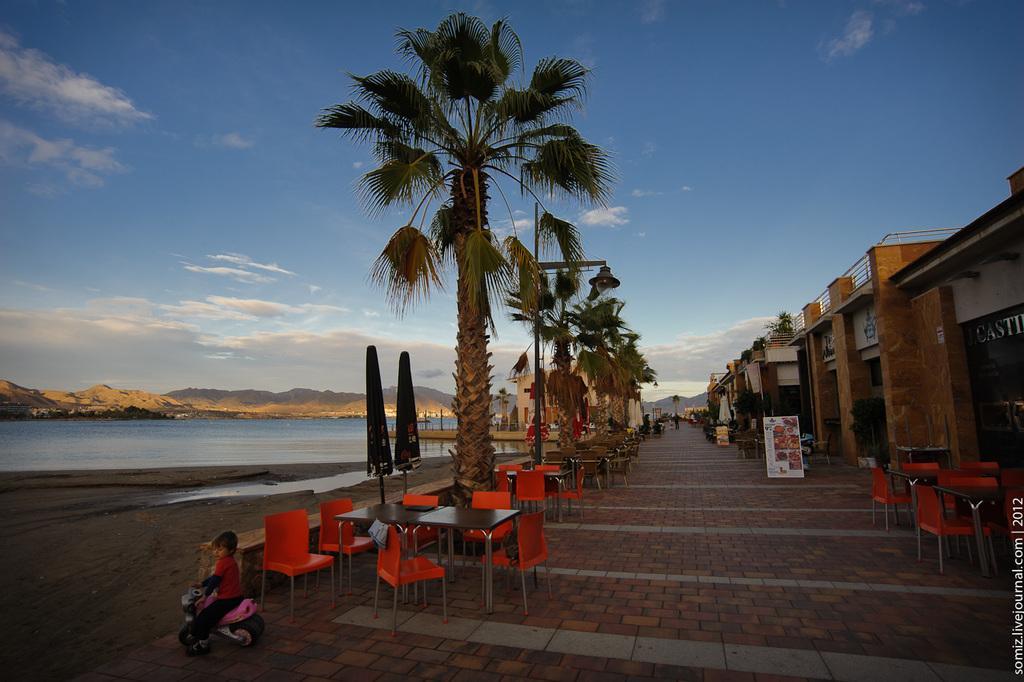Can you describe this image briefly? This image is clicked near the beach. In the front, there are coconut trees along with the chairs and tables. To the right, there are stalls and small buildings. To the left, there is water along with the mountains. At the top, there is a sky. 